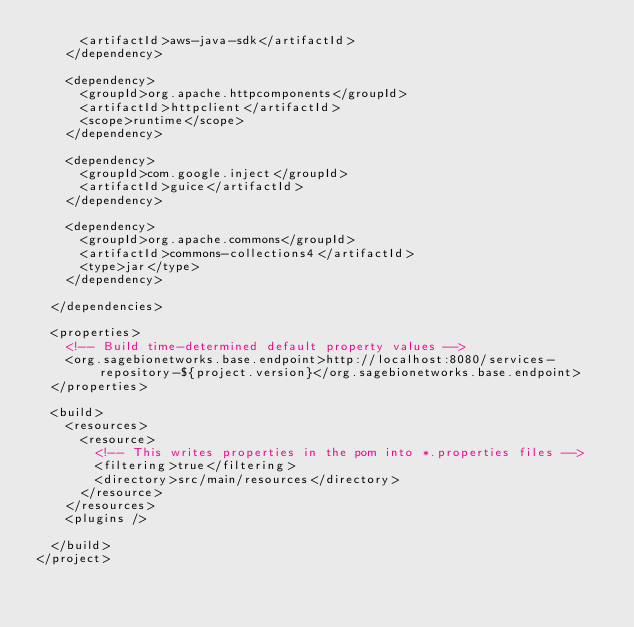Convert code to text. <code><loc_0><loc_0><loc_500><loc_500><_XML_>			<artifactId>aws-java-sdk</artifactId>
		</dependency>

		<dependency>
			<groupId>org.apache.httpcomponents</groupId>
			<artifactId>httpclient</artifactId>
			<scope>runtime</scope>
		</dependency>

		<dependency>
			<groupId>com.google.inject</groupId>
			<artifactId>guice</artifactId>
		</dependency>

		<dependency>
			<groupId>org.apache.commons</groupId>
			<artifactId>commons-collections4</artifactId>
			<type>jar</type>
		</dependency>

	</dependencies>

	<properties>
		<!-- Build time-determined default property values -->
		<org.sagebionetworks.base.endpoint>http://localhost:8080/services-repository-${project.version}</org.sagebionetworks.base.endpoint>
	</properties>

	<build>
		<resources>
			<resource>
				<!-- This writes properties in the pom into *.properties files -->
				<filtering>true</filtering>
				<directory>src/main/resources</directory>
			</resource>
		</resources>
		<plugins />

	</build>
</project>
</code> 